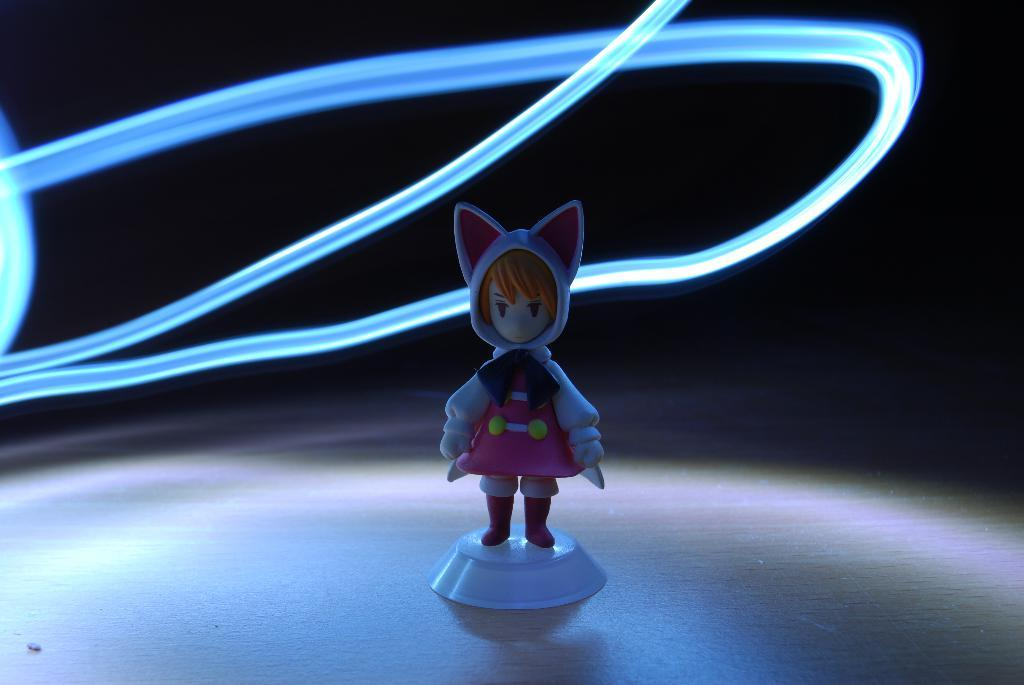What is the main subject in the middle of the image? There is a toy in the middle of the image. How would you describe the overall appearance of the image? The background of the image is dark. Are there any additional elements visible in the image? Yes, there are rope lights in the image. Can you see any visible veins in the toy in the image? There are no visible veins in the toy, as it is not a living organism. What type of attraction is depicted in the image? There is no attraction present in the image; it features a toy and rope lights. 